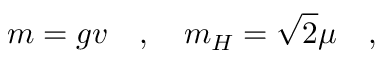Convert formula to latex. <formula><loc_0><loc_0><loc_500><loc_500>m = g v \quad , \quad m _ { H } = \sqrt { 2 } \mu \quad ,</formula> 